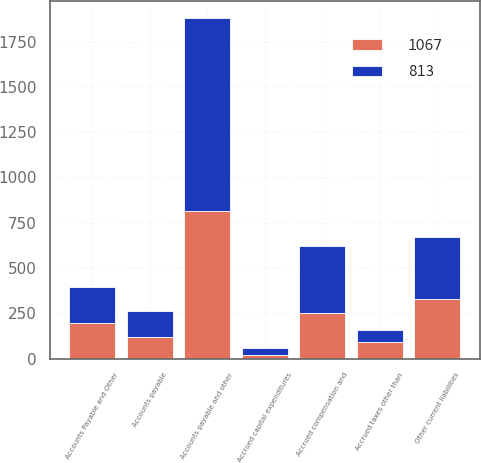<chart> <loc_0><loc_0><loc_500><loc_500><stacked_bar_chart><ecel><fcel>Accounts Payable and Other<fcel>Accounts payable<fcel>Accrued capital expenditures<fcel>Accrued compensation and<fcel>Accrued taxes other than<fcel>Other current liabilities<fcel>Accounts payable and other<nl><fcel>1067<fcel>197<fcel>119<fcel>21<fcel>252<fcel>90<fcel>331<fcel>813<nl><fcel>813<fcel>197<fcel>142<fcel>39<fcel>372<fcel>66<fcel>342<fcel>1067<nl></chart> 